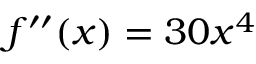<formula> <loc_0><loc_0><loc_500><loc_500>f ^ { \prime \prime } ( x ) = 3 0 x ^ { 4 }</formula> 